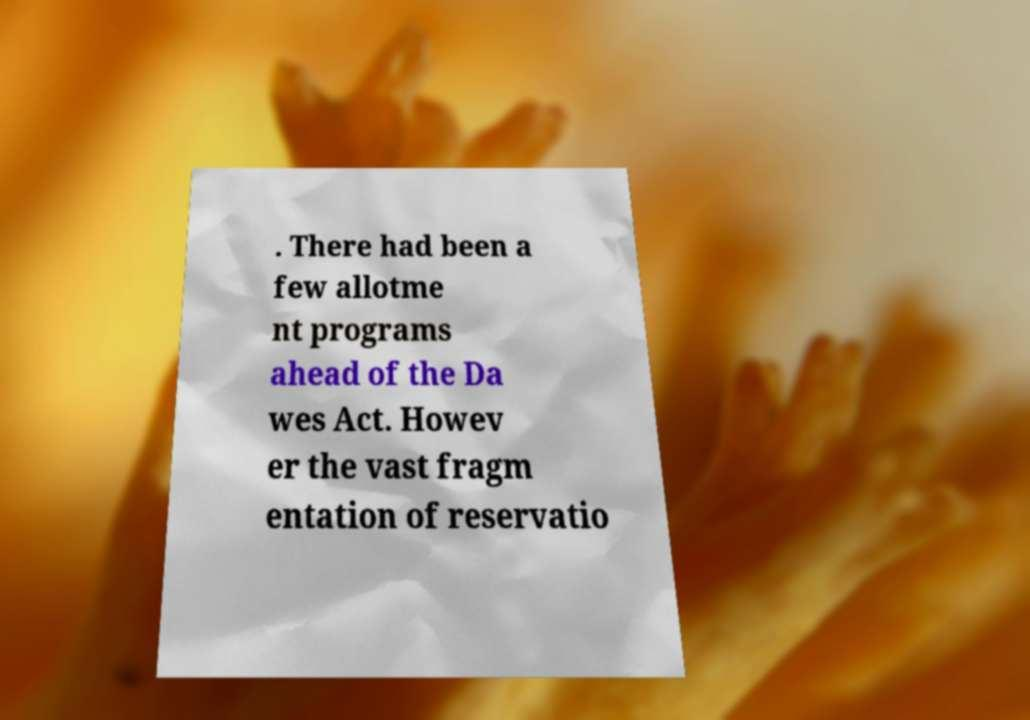Can you accurately transcribe the text from the provided image for me? . There had been a few allotme nt programs ahead of the Da wes Act. Howev er the vast fragm entation of reservatio 